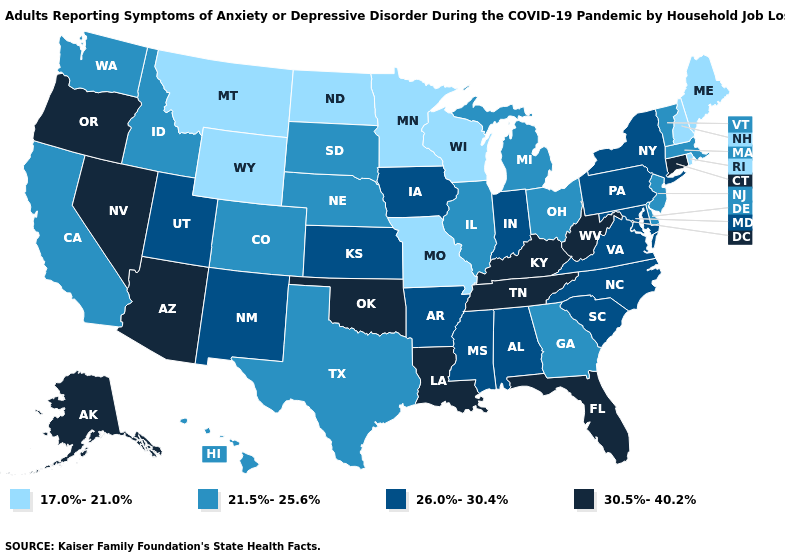Does Rhode Island have a lower value than Washington?
Answer briefly. Yes. What is the highest value in the USA?
Answer briefly. 30.5%-40.2%. Does the map have missing data?
Write a very short answer. No. What is the value of South Dakota?
Be succinct. 21.5%-25.6%. What is the value of Illinois?
Concise answer only. 21.5%-25.6%. What is the value of Vermont?
Give a very brief answer. 21.5%-25.6%. What is the value of Virginia?
Be succinct. 26.0%-30.4%. What is the value of North Carolina?
Keep it brief. 26.0%-30.4%. Does Oklahoma have the highest value in the USA?
Answer briefly. Yes. What is the value of North Carolina?
Answer briefly. 26.0%-30.4%. How many symbols are there in the legend?
Quick response, please. 4. Name the states that have a value in the range 21.5%-25.6%?
Short answer required. California, Colorado, Delaware, Georgia, Hawaii, Idaho, Illinois, Massachusetts, Michigan, Nebraska, New Jersey, Ohio, South Dakota, Texas, Vermont, Washington. Name the states that have a value in the range 17.0%-21.0%?
Quick response, please. Maine, Minnesota, Missouri, Montana, New Hampshire, North Dakota, Rhode Island, Wisconsin, Wyoming. Does Washington have a higher value than Minnesota?
Keep it brief. Yes. Name the states that have a value in the range 17.0%-21.0%?
Keep it brief. Maine, Minnesota, Missouri, Montana, New Hampshire, North Dakota, Rhode Island, Wisconsin, Wyoming. 